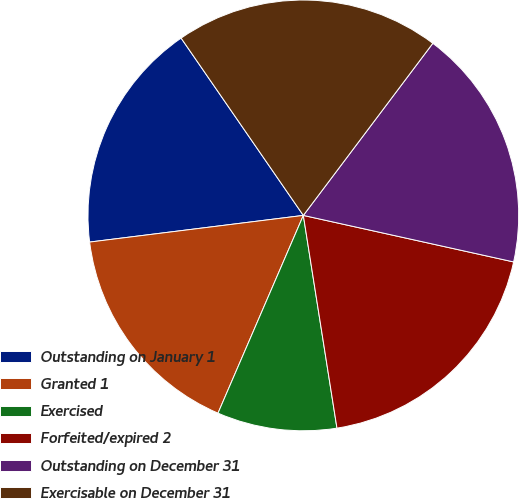Convert chart. <chart><loc_0><loc_0><loc_500><loc_500><pie_chart><fcel>Outstanding on January 1<fcel>Granted 1<fcel>Exercised<fcel>Forfeited/expired 2<fcel>Outstanding on December 31<fcel>Exercisable on December 31<nl><fcel>17.37%<fcel>16.54%<fcel>8.98%<fcel>19.04%<fcel>18.2%<fcel>19.87%<nl></chart> 